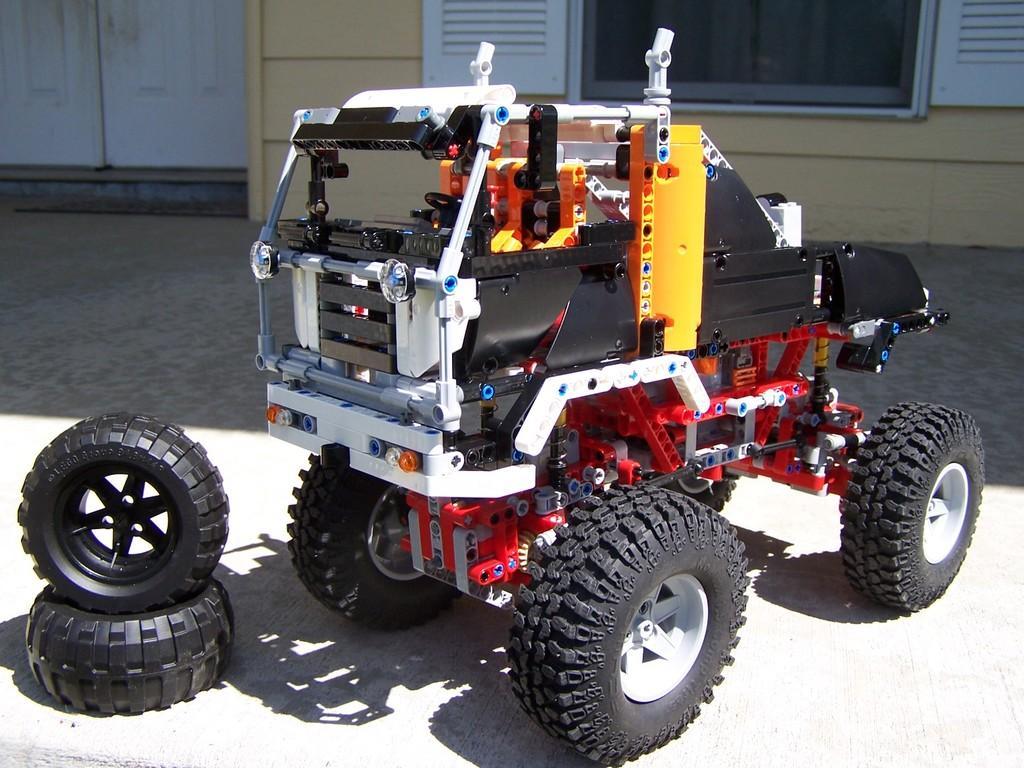Could you give a brief overview of what you see in this image? In this image there is a vehicle, behind the vehicle there are tires. In front of the vehicle there are glass windows and wooden door on the wall. 